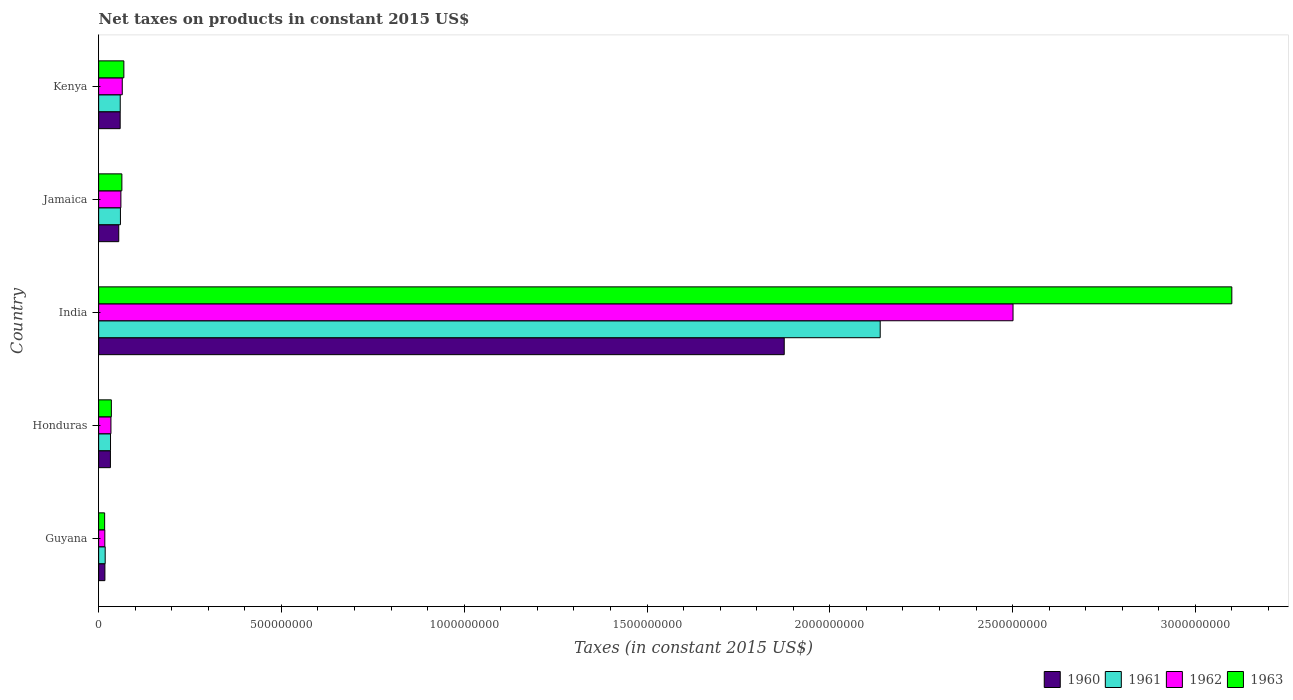How many groups of bars are there?
Your response must be concise. 5. Are the number of bars per tick equal to the number of legend labels?
Give a very brief answer. Yes. Are the number of bars on each tick of the Y-axis equal?
Your answer should be compact. Yes. How many bars are there on the 5th tick from the bottom?
Make the answer very short. 4. What is the label of the 1st group of bars from the top?
Your answer should be very brief. Kenya. In how many cases, is the number of bars for a given country not equal to the number of legend labels?
Give a very brief answer. 0. What is the net taxes on products in 1960 in Honduras?
Make the answer very short. 3.22e+07. Across all countries, what is the maximum net taxes on products in 1963?
Your answer should be very brief. 3.10e+09. Across all countries, what is the minimum net taxes on products in 1963?
Offer a terse response. 1.64e+07. In which country was the net taxes on products in 1961 maximum?
Your response must be concise. India. In which country was the net taxes on products in 1961 minimum?
Your answer should be very brief. Guyana. What is the total net taxes on products in 1960 in the graph?
Offer a terse response. 2.04e+09. What is the difference between the net taxes on products in 1962 in Guyana and that in Kenya?
Keep it short and to the point. -4.77e+07. What is the difference between the net taxes on products in 1960 in Jamaica and the net taxes on products in 1961 in India?
Give a very brief answer. -2.08e+09. What is the average net taxes on products in 1960 per country?
Make the answer very short. 4.08e+08. What is the difference between the net taxes on products in 1961 and net taxes on products in 1960 in Jamaica?
Offer a very short reply. 4.62e+06. What is the ratio of the net taxes on products in 1963 in Guyana to that in Kenya?
Your response must be concise. 0.24. What is the difference between the highest and the second highest net taxes on products in 1960?
Give a very brief answer. 1.82e+09. What is the difference between the highest and the lowest net taxes on products in 1960?
Offer a very short reply. 1.86e+09. Is the sum of the net taxes on products in 1963 in Guyana and India greater than the maximum net taxes on products in 1962 across all countries?
Offer a very short reply. Yes. Is it the case that in every country, the sum of the net taxes on products in 1960 and net taxes on products in 1963 is greater than the sum of net taxes on products in 1962 and net taxes on products in 1961?
Your response must be concise. No. Is it the case that in every country, the sum of the net taxes on products in 1960 and net taxes on products in 1962 is greater than the net taxes on products in 1963?
Provide a short and direct response. Yes. How many bars are there?
Provide a short and direct response. 20. Does the graph contain grids?
Offer a very short reply. No. How many legend labels are there?
Your answer should be very brief. 4. How are the legend labels stacked?
Your answer should be very brief. Horizontal. What is the title of the graph?
Make the answer very short. Net taxes on products in constant 2015 US$. What is the label or title of the X-axis?
Your answer should be very brief. Taxes (in constant 2015 US$). What is the Taxes (in constant 2015 US$) in 1960 in Guyana?
Offer a terse response. 1.71e+07. What is the Taxes (in constant 2015 US$) of 1961 in Guyana?
Give a very brief answer. 1.79e+07. What is the Taxes (in constant 2015 US$) in 1962 in Guyana?
Provide a succinct answer. 1.69e+07. What is the Taxes (in constant 2015 US$) of 1963 in Guyana?
Your answer should be compact. 1.64e+07. What is the Taxes (in constant 2015 US$) in 1960 in Honduras?
Make the answer very short. 3.22e+07. What is the Taxes (in constant 2015 US$) in 1961 in Honduras?
Ensure brevity in your answer.  3.25e+07. What is the Taxes (in constant 2015 US$) in 1962 in Honduras?
Give a very brief answer. 3.36e+07. What is the Taxes (in constant 2015 US$) in 1963 in Honduras?
Your response must be concise. 3.48e+07. What is the Taxes (in constant 2015 US$) of 1960 in India?
Offer a very short reply. 1.88e+09. What is the Taxes (in constant 2015 US$) of 1961 in India?
Provide a succinct answer. 2.14e+09. What is the Taxes (in constant 2015 US$) in 1962 in India?
Keep it short and to the point. 2.50e+09. What is the Taxes (in constant 2015 US$) of 1963 in India?
Provide a succinct answer. 3.10e+09. What is the Taxes (in constant 2015 US$) of 1960 in Jamaica?
Provide a succinct answer. 5.50e+07. What is the Taxes (in constant 2015 US$) in 1961 in Jamaica?
Make the answer very short. 5.96e+07. What is the Taxes (in constant 2015 US$) of 1962 in Jamaica?
Ensure brevity in your answer.  6.09e+07. What is the Taxes (in constant 2015 US$) in 1963 in Jamaica?
Give a very brief answer. 6.36e+07. What is the Taxes (in constant 2015 US$) of 1960 in Kenya?
Provide a succinct answer. 5.89e+07. What is the Taxes (in constant 2015 US$) of 1961 in Kenya?
Ensure brevity in your answer.  5.91e+07. What is the Taxes (in constant 2015 US$) of 1962 in Kenya?
Provide a succinct answer. 6.47e+07. What is the Taxes (in constant 2015 US$) of 1963 in Kenya?
Keep it short and to the point. 6.90e+07. Across all countries, what is the maximum Taxes (in constant 2015 US$) in 1960?
Keep it short and to the point. 1.88e+09. Across all countries, what is the maximum Taxes (in constant 2015 US$) in 1961?
Ensure brevity in your answer.  2.14e+09. Across all countries, what is the maximum Taxes (in constant 2015 US$) in 1962?
Provide a short and direct response. 2.50e+09. Across all countries, what is the maximum Taxes (in constant 2015 US$) in 1963?
Your response must be concise. 3.10e+09. Across all countries, what is the minimum Taxes (in constant 2015 US$) of 1960?
Your answer should be compact. 1.71e+07. Across all countries, what is the minimum Taxes (in constant 2015 US$) of 1961?
Your response must be concise. 1.79e+07. Across all countries, what is the minimum Taxes (in constant 2015 US$) of 1962?
Provide a short and direct response. 1.69e+07. Across all countries, what is the minimum Taxes (in constant 2015 US$) of 1963?
Provide a short and direct response. 1.64e+07. What is the total Taxes (in constant 2015 US$) in 1960 in the graph?
Your answer should be very brief. 2.04e+09. What is the total Taxes (in constant 2015 US$) of 1961 in the graph?
Your response must be concise. 2.31e+09. What is the total Taxes (in constant 2015 US$) in 1962 in the graph?
Offer a very short reply. 2.68e+09. What is the total Taxes (in constant 2015 US$) in 1963 in the graph?
Make the answer very short. 3.28e+09. What is the difference between the Taxes (in constant 2015 US$) in 1960 in Guyana and that in Honduras?
Provide a succinct answer. -1.51e+07. What is the difference between the Taxes (in constant 2015 US$) of 1961 in Guyana and that in Honduras?
Provide a succinct answer. -1.46e+07. What is the difference between the Taxes (in constant 2015 US$) in 1962 in Guyana and that in Honduras?
Make the answer very short. -1.67e+07. What is the difference between the Taxes (in constant 2015 US$) of 1963 in Guyana and that in Honduras?
Offer a terse response. -1.84e+07. What is the difference between the Taxes (in constant 2015 US$) in 1960 in Guyana and that in India?
Your response must be concise. -1.86e+09. What is the difference between the Taxes (in constant 2015 US$) in 1961 in Guyana and that in India?
Give a very brief answer. -2.12e+09. What is the difference between the Taxes (in constant 2015 US$) in 1962 in Guyana and that in India?
Offer a very short reply. -2.48e+09. What is the difference between the Taxes (in constant 2015 US$) of 1963 in Guyana and that in India?
Give a very brief answer. -3.08e+09. What is the difference between the Taxes (in constant 2015 US$) in 1960 in Guyana and that in Jamaica?
Give a very brief answer. -3.79e+07. What is the difference between the Taxes (in constant 2015 US$) of 1961 in Guyana and that in Jamaica?
Offer a very short reply. -4.17e+07. What is the difference between the Taxes (in constant 2015 US$) in 1962 in Guyana and that in Jamaica?
Make the answer very short. -4.40e+07. What is the difference between the Taxes (in constant 2015 US$) in 1963 in Guyana and that in Jamaica?
Give a very brief answer. -4.71e+07. What is the difference between the Taxes (in constant 2015 US$) of 1960 in Guyana and that in Kenya?
Offer a very short reply. -4.18e+07. What is the difference between the Taxes (in constant 2015 US$) in 1961 in Guyana and that in Kenya?
Provide a succinct answer. -4.12e+07. What is the difference between the Taxes (in constant 2015 US$) of 1962 in Guyana and that in Kenya?
Offer a terse response. -4.77e+07. What is the difference between the Taxes (in constant 2015 US$) in 1963 in Guyana and that in Kenya?
Make the answer very short. -5.26e+07. What is the difference between the Taxes (in constant 2015 US$) of 1960 in Honduras and that in India?
Give a very brief answer. -1.84e+09. What is the difference between the Taxes (in constant 2015 US$) of 1961 in Honduras and that in India?
Provide a short and direct response. -2.11e+09. What is the difference between the Taxes (in constant 2015 US$) of 1962 in Honduras and that in India?
Your answer should be compact. -2.47e+09. What is the difference between the Taxes (in constant 2015 US$) of 1963 in Honduras and that in India?
Offer a terse response. -3.06e+09. What is the difference between the Taxes (in constant 2015 US$) of 1960 in Honduras and that in Jamaica?
Offer a terse response. -2.28e+07. What is the difference between the Taxes (in constant 2015 US$) of 1961 in Honduras and that in Jamaica?
Your answer should be compact. -2.71e+07. What is the difference between the Taxes (in constant 2015 US$) of 1962 in Honduras and that in Jamaica?
Make the answer very short. -2.72e+07. What is the difference between the Taxes (in constant 2015 US$) in 1963 in Honduras and that in Jamaica?
Your answer should be compact. -2.88e+07. What is the difference between the Taxes (in constant 2015 US$) in 1960 in Honduras and that in Kenya?
Your answer should be compact. -2.67e+07. What is the difference between the Taxes (in constant 2015 US$) in 1961 in Honduras and that in Kenya?
Provide a short and direct response. -2.66e+07. What is the difference between the Taxes (in constant 2015 US$) in 1962 in Honduras and that in Kenya?
Your answer should be very brief. -3.10e+07. What is the difference between the Taxes (in constant 2015 US$) in 1963 in Honduras and that in Kenya?
Ensure brevity in your answer.  -3.42e+07. What is the difference between the Taxes (in constant 2015 US$) of 1960 in India and that in Jamaica?
Your response must be concise. 1.82e+09. What is the difference between the Taxes (in constant 2015 US$) in 1961 in India and that in Jamaica?
Your answer should be compact. 2.08e+09. What is the difference between the Taxes (in constant 2015 US$) in 1962 in India and that in Jamaica?
Provide a succinct answer. 2.44e+09. What is the difference between the Taxes (in constant 2015 US$) of 1963 in India and that in Jamaica?
Your answer should be very brief. 3.04e+09. What is the difference between the Taxes (in constant 2015 US$) in 1960 in India and that in Kenya?
Your answer should be compact. 1.82e+09. What is the difference between the Taxes (in constant 2015 US$) of 1961 in India and that in Kenya?
Make the answer very short. 2.08e+09. What is the difference between the Taxes (in constant 2015 US$) in 1962 in India and that in Kenya?
Make the answer very short. 2.44e+09. What is the difference between the Taxes (in constant 2015 US$) of 1963 in India and that in Kenya?
Give a very brief answer. 3.03e+09. What is the difference between the Taxes (in constant 2015 US$) in 1960 in Jamaica and that in Kenya?
Make the answer very short. -3.91e+06. What is the difference between the Taxes (in constant 2015 US$) of 1961 in Jamaica and that in Kenya?
Offer a terse response. 5.74e+05. What is the difference between the Taxes (in constant 2015 US$) in 1962 in Jamaica and that in Kenya?
Your response must be concise. -3.75e+06. What is the difference between the Taxes (in constant 2015 US$) of 1963 in Jamaica and that in Kenya?
Your response must be concise. -5.46e+06. What is the difference between the Taxes (in constant 2015 US$) in 1960 in Guyana and the Taxes (in constant 2015 US$) in 1961 in Honduras?
Offer a very short reply. -1.54e+07. What is the difference between the Taxes (in constant 2015 US$) in 1960 in Guyana and the Taxes (in constant 2015 US$) in 1962 in Honduras?
Offer a terse response. -1.65e+07. What is the difference between the Taxes (in constant 2015 US$) of 1960 in Guyana and the Taxes (in constant 2015 US$) of 1963 in Honduras?
Give a very brief answer. -1.77e+07. What is the difference between the Taxes (in constant 2015 US$) of 1961 in Guyana and the Taxes (in constant 2015 US$) of 1962 in Honduras?
Your answer should be compact. -1.57e+07. What is the difference between the Taxes (in constant 2015 US$) of 1961 in Guyana and the Taxes (in constant 2015 US$) of 1963 in Honduras?
Your answer should be very brief. -1.69e+07. What is the difference between the Taxes (in constant 2015 US$) of 1962 in Guyana and the Taxes (in constant 2015 US$) of 1963 in Honduras?
Your answer should be very brief. -1.79e+07. What is the difference between the Taxes (in constant 2015 US$) of 1960 in Guyana and the Taxes (in constant 2015 US$) of 1961 in India?
Provide a short and direct response. -2.12e+09. What is the difference between the Taxes (in constant 2015 US$) in 1960 in Guyana and the Taxes (in constant 2015 US$) in 1962 in India?
Make the answer very short. -2.48e+09. What is the difference between the Taxes (in constant 2015 US$) in 1960 in Guyana and the Taxes (in constant 2015 US$) in 1963 in India?
Make the answer very short. -3.08e+09. What is the difference between the Taxes (in constant 2015 US$) in 1961 in Guyana and the Taxes (in constant 2015 US$) in 1962 in India?
Give a very brief answer. -2.48e+09. What is the difference between the Taxes (in constant 2015 US$) of 1961 in Guyana and the Taxes (in constant 2015 US$) of 1963 in India?
Provide a succinct answer. -3.08e+09. What is the difference between the Taxes (in constant 2015 US$) in 1962 in Guyana and the Taxes (in constant 2015 US$) in 1963 in India?
Provide a succinct answer. -3.08e+09. What is the difference between the Taxes (in constant 2015 US$) in 1960 in Guyana and the Taxes (in constant 2015 US$) in 1961 in Jamaica?
Provide a short and direct response. -4.25e+07. What is the difference between the Taxes (in constant 2015 US$) in 1960 in Guyana and the Taxes (in constant 2015 US$) in 1962 in Jamaica?
Offer a very short reply. -4.38e+07. What is the difference between the Taxes (in constant 2015 US$) in 1960 in Guyana and the Taxes (in constant 2015 US$) in 1963 in Jamaica?
Offer a very short reply. -4.64e+07. What is the difference between the Taxes (in constant 2015 US$) in 1961 in Guyana and the Taxes (in constant 2015 US$) in 1962 in Jamaica?
Provide a short and direct response. -4.30e+07. What is the difference between the Taxes (in constant 2015 US$) of 1961 in Guyana and the Taxes (in constant 2015 US$) of 1963 in Jamaica?
Give a very brief answer. -4.57e+07. What is the difference between the Taxes (in constant 2015 US$) of 1962 in Guyana and the Taxes (in constant 2015 US$) of 1963 in Jamaica?
Give a very brief answer. -4.66e+07. What is the difference between the Taxes (in constant 2015 US$) in 1960 in Guyana and the Taxes (in constant 2015 US$) in 1961 in Kenya?
Offer a very short reply. -4.19e+07. What is the difference between the Taxes (in constant 2015 US$) in 1960 in Guyana and the Taxes (in constant 2015 US$) in 1962 in Kenya?
Provide a succinct answer. -4.75e+07. What is the difference between the Taxes (in constant 2015 US$) of 1960 in Guyana and the Taxes (in constant 2015 US$) of 1963 in Kenya?
Keep it short and to the point. -5.19e+07. What is the difference between the Taxes (in constant 2015 US$) of 1961 in Guyana and the Taxes (in constant 2015 US$) of 1962 in Kenya?
Offer a very short reply. -4.67e+07. What is the difference between the Taxes (in constant 2015 US$) in 1961 in Guyana and the Taxes (in constant 2015 US$) in 1963 in Kenya?
Make the answer very short. -5.11e+07. What is the difference between the Taxes (in constant 2015 US$) of 1962 in Guyana and the Taxes (in constant 2015 US$) of 1963 in Kenya?
Your answer should be very brief. -5.21e+07. What is the difference between the Taxes (in constant 2015 US$) of 1960 in Honduras and the Taxes (in constant 2015 US$) of 1961 in India?
Ensure brevity in your answer.  -2.11e+09. What is the difference between the Taxes (in constant 2015 US$) in 1960 in Honduras and the Taxes (in constant 2015 US$) in 1962 in India?
Provide a short and direct response. -2.47e+09. What is the difference between the Taxes (in constant 2015 US$) of 1960 in Honduras and the Taxes (in constant 2015 US$) of 1963 in India?
Make the answer very short. -3.07e+09. What is the difference between the Taxes (in constant 2015 US$) of 1961 in Honduras and the Taxes (in constant 2015 US$) of 1962 in India?
Provide a short and direct response. -2.47e+09. What is the difference between the Taxes (in constant 2015 US$) of 1961 in Honduras and the Taxes (in constant 2015 US$) of 1963 in India?
Make the answer very short. -3.07e+09. What is the difference between the Taxes (in constant 2015 US$) of 1962 in Honduras and the Taxes (in constant 2015 US$) of 1963 in India?
Offer a terse response. -3.07e+09. What is the difference between the Taxes (in constant 2015 US$) in 1960 in Honduras and the Taxes (in constant 2015 US$) in 1961 in Jamaica?
Ensure brevity in your answer.  -2.74e+07. What is the difference between the Taxes (in constant 2015 US$) of 1960 in Honduras and the Taxes (in constant 2015 US$) of 1962 in Jamaica?
Make the answer very short. -2.86e+07. What is the difference between the Taxes (in constant 2015 US$) of 1960 in Honduras and the Taxes (in constant 2015 US$) of 1963 in Jamaica?
Offer a very short reply. -3.13e+07. What is the difference between the Taxes (in constant 2015 US$) in 1961 in Honduras and the Taxes (in constant 2015 US$) in 1962 in Jamaica?
Provide a short and direct response. -2.84e+07. What is the difference between the Taxes (in constant 2015 US$) in 1961 in Honduras and the Taxes (in constant 2015 US$) in 1963 in Jamaica?
Make the answer very short. -3.11e+07. What is the difference between the Taxes (in constant 2015 US$) in 1962 in Honduras and the Taxes (in constant 2015 US$) in 1963 in Jamaica?
Provide a succinct answer. -2.99e+07. What is the difference between the Taxes (in constant 2015 US$) in 1960 in Honduras and the Taxes (in constant 2015 US$) in 1961 in Kenya?
Your answer should be very brief. -2.68e+07. What is the difference between the Taxes (in constant 2015 US$) of 1960 in Honduras and the Taxes (in constant 2015 US$) of 1962 in Kenya?
Ensure brevity in your answer.  -3.24e+07. What is the difference between the Taxes (in constant 2015 US$) of 1960 in Honduras and the Taxes (in constant 2015 US$) of 1963 in Kenya?
Your answer should be compact. -3.68e+07. What is the difference between the Taxes (in constant 2015 US$) of 1961 in Honduras and the Taxes (in constant 2015 US$) of 1962 in Kenya?
Ensure brevity in your answer.  -3.22e+07. What is the difference between the Taxes (in constant 2015 US$) of 1961 in Honduras and the Taxes (in constant 2015 US$) of 1963 in Kenya?
Offer a very short reply. -3.65e+07. What is the difference between the Taxes (in constant 2015 US$) in 1962 in Honduras and the Taxes (in constant 2015 US$) in 1963 in Kenya?
Your response must be concise. -3.54e+07. What is the difference between the Taxes (in constant 2015 US$) of 1960 in India and the Taxes (in constant 2015 US$) of 1961 in Jamaica?
Provide a short and direct response. 1.82e+09. What is the difference between the Taxes (in constant 2015 US$) in 1960 in India and the Taxes (in constant 2015 US$) in 1962 in Jamaica?
Give a very brief answer. 1.81e+09. What is the difference between the Taxes (in constant 2015 US$) of 1960 in India and the Taxes (in constant 2015 US$) of 1963 in Jamaica?
Make the answer very short. 1.81e+09. What is the difference between the Taxes (in constant 2015 US$) of 1961 in India and the Taxes (in constant 2015 US$) of 1962 in Jamaica?
Your answer should be very brief. 2.08e+09. What is the difference between the Taxes (in constant 2015 US$) of 1961 in India and the Taxes (in constant 2015 US$) of 1963 in Jamaica?
Provide a short and direct response. 2.07e+09. What is the difference between the Taxes (in constant 2015 US$) of 1962 in India and the Taxes (in constant 2015 US$) of 1963 in Jamaica?
Give a very brief answer. 2.44e+09. What is the difference between the Taxes (in constant 2015 US$) in 1960 in India and the Taxes (in constant 2015 US$) in 1961 in Kenya?
Keep it short and to the point. 1.82e+09. What is the difference between the Taxes (in constant 2015 US$) in 1960 in India and the Taxes (in constant 2015 US$) in 1962 in Kenya?
Provide a short and direct response. 1.81e+09. What is the difference between the Taxes (in constant 2015 US$) in 1960 in India and the Taxes (in constant 2015 US$) in 1963 in Kenya?
Ensure brevity in your answer.  1.81e+09. What is the difference between the Taxes (in constant 2015 US$) of 1961 in India and the Taxes (in constant 2015 US$) of 1962 in Kenya?
Keep it short and to the point. 2.07e+09. What is the difference between the Taxes (in constant 2015 US$) of 1961 in India and the Taxes (in constant 2015 US$) of 1963 in Kenya?
Your response must be concise. 2.07e+09. What is the difference between the Taxes (in constant 2015 US$) in 1962 in India and the Taxes (in constant 2015 US$) in 1963 in Kenya?
Your answer should be very brief. 2.43e+09. What is the difference between the Taxes (in constant 2015 US$) of 1960 in Jamaica and the Taxes (in constant 2015 US$) of 1961 in Kenya?
Your response must be concise. -4.05e+06. What is the difference between the Taxes (in constant 2015 US$) of 1960 in Jamaica and the Taxes (in constant 2015 US$) of 1962 in Kenya?
Keep it short and to the point. -9.63e+06. What is the difference between the Taxes (in constant 2015 US$) in 1960 in Jamaica and the Taxes (in constant 2015 US$) in 1963 in Kenya?
Offer a very short reply. -1.40e+07. What is the difference between the Taxes (in constant 2015 US$) of 1961 in Jamaica and the Taxes (in constant 2015 US$) of 1962 in Kenya?
Your answer should be compact. -5.01e+06. What is the difference between the Taxes (in constant 2015 US$) in 1961 in Jamaica and the Taxes (in constant 2015 US$) in 1963 in Kenya?
Provide a succinct answer. -9.38e+06. What is the difference between the Taxes (in constant 2015 US$) in 1962 in Jamaica and the Taxes (in constant 2015 US$) in 1963 in Kenya?
Make the answer very short. -8.12e+06. What is the average Taxes (in constant 2015 US$) of 1960 per country?
Give a very brief answer. 4.08e+08. What is the average Taxes (in constant 2015 US$) in 1961 per country?
Offer a very short reply. 4.61e+08. What is the average Taxes (in constant 2015 US$) of 1962 per country?
Your answer should be very brief. 5.35e+08. What is the average Taxes (in constant 2015 US$) in 1963 per country?
Offer a very short reply. 6.57e+08. What is the difference between the Taxes (in constant 2015 US$) of 1960 and Taxes (in constant 2015 US$) of 1961 in Guyana?
Keep it short and to the point. -7.58e+05. What is the difference between the Taxes (in constant 2015 US$) of 1960 and Taxes (in constant 2015 US$) of 1962 in Guyana?
Your answer should be very brief. 2.33e+05. What is the difference between the Taxes (in constant 2015 US$) in 1960 and Taxes (in constant 2015 US$) in 1963 in Guyana?
Your answer should be very brief. 7.00e+05. What is the difference between the Taxes (in constant 2015 US$) of 1961 and Taxes (in constant 2015 US$) of 1962 in Guyana?
Your answer should be compact. 9.92e+05. What is the difference between the Taxes (in constant 2015 US$) in 1961 and Taxes (in constant 2015 US$) in 1963 in Guyana?
Provide a succinct answer. 1.46e+06. What is the difference between the Taxes (in constant 2015 US$) of 1962 and Taxes (in constant 2015 US$) of 1963 in Guyana?
Your answer should be compact. 4.67e+05. What is the difference between the Taxes (in constant 2015 US$) of 1960 and Taxes (in constant 2015 US$) of 1961 in Honduras?
Offer a terse response. -2.50e+05. What is the difference between the Taxes (in constant 2015 US$) in 1960 and Taxes (in constant 2015 US$) in 1962 in Honduras?
Your response must be concise. -1.40e+06. What is the difference between the Taxes (in constant 2015 US$) in 1960 and Taxes (in constant 2015 US$) in 1963 in Honduras?
Your response must be concise. -2.55e+06. What is the difference between the Taxes (in constant 2015 US$) of 1961 and Taxes (in constant 2015 US$) of 1962 in Honduras?
Your answer should be compact. -1.15e+06. What is the difference between the Taxes (in constant 2015 US$) of 1961 and Taxes (in constant 2015 US$) of 1963 in Honduras?
Ensure brevity in your answer.  -2.30e+06. What is the difference between the Taxes (in constant 2015 US$) of 1962 and Taxes (in constant 2015 US$) of 1963 in Honduras?
Keep it short and to the point. -1.15e+06. What is the difference between the Taxes (in constant 2015 US$) of 1960 and Taxes (in constant 2015 US$) of 1961 in India?
Make the answer very short. -2.63e+08. What is the difference between the Taxes (in constant 2015 US$) of 1960 and Taxes (in constant 2015 US$) of 1962 in India?
Your response must be concise. -6.26e+08. What is the difference between the Taxes (in constant 2015 US$) in 1960 and Taxes (in constant 2015 US$) in 1963 in India?
Offer a terse response. -1.22e+09. What is the difference between the Taxes (in constant 2015 US$) in 1961 and Taxes (in constant 2015 US$) in 1962 in India?
Make the answer very short. -3.63e+08. What is the difference between the Taxes (in constant 2015 US$) of 1961 and Taxes (in constant 2015 US$) of 1963 in India?
Make the answer very short. -9.62e+08. What is the difference between the Taxes (in constant 2015 US$) in 1962 and Taxes (in constant 2015 US$) in 1963 in India?
Provide a succinct answer. -5.99e+08. What is the difference between the Taxes (in constant 2015 US$) in 1960 and Taxes (in constant 2015 US$) in 1961 in Jamaica?
Offer a terse response. -4.62e+06. What is the difference between the Taxes (in constant 2015 US$) of 1960 and Taxes (in constant 2015 US$) of 1962 in Jamaica?
Offer a very short reply. -5.88e+06. What is the difference between the Taxes (in constant 2015 US$) of 1960 and Taxes (in constant 2015 US$) of 1963 in Jamaica?
Your response must be concise. -8.54e+06. What is the difference between the Taxes (in constant 2015 US$) in 1961 and Taxes (in constant 2015 US$) in 1962 in Jamaica?
Your answer should be very brief. -1.26e+06. What is the difference between the Taxes (in constant 2015 US$) of 1961 and Taxes (in constant 2015 US$) of 1963 in Jamaica?
Ensure brevity in your answer.  -3.92e+06. What is the difference between the Taxes (in constant 2015 US$) in 1962 and Taxes (in constant 2015 US$) in 1963 in Jamaica?
Offer a terse response. -2.66e+06. What is the difference between the Taxes (in constant 2015 US$) in 1960 and Taxes (in constant 2015 US$) in 1961 in Kenya?
Your response must be concise. -1.40e+05. What is the difference between the Taxes (in constant 2015 US$) of 1960 and Taxes (in constant 2015 US$) of 1962 in Kenya?
Provide a succinct answer. -5.73e+06. What is the difference between the Taxes (in constant 2015 US$) in 1960 and Taxes (in constant 2015 US$) in 1963 in Kenya?
Your answer should be compact. -1.01e+07. What is the difference between the Taxes (in constant 2015 US$) of 1961 and Taxes (in constant 2015 US$) of 1962 in Kenya?
Your answer should be compact. -5.59e+06. What is the difference between the Taxes (in constant 2015 US$) of 1961 and Taxes (in constant 2015 US$) of 1963 in Kenya?
Provide a short and direct response. -9.95e+06. What is the difference between the Taxes (in constant 2015 US$) in 1962 and Taxes (in constant 2015 US$) in 1963 in Kenya?
Offer a very short reply. -4.37e+06. What is the ratio of the Taxes (in constant 2015 US$) of 1960 in Guyana to that in Honduras?
Give a very brief answer. 0.53. What is the ratio of the Taxes (in constant 2015 US$) of 1961 in Guyana to that in Honduras?
Keep it short and to the point. 0.55. What is the ratio of the Taxes (in constant 2015 US$) of 1962 in Guyana to that in Honduras?
Provide a succinct answer. 0.5. What is the ratio of the Taxes (in constant 2015 US$) in 1963 in Guyana to that in Honduras?
Offer a terse response. 0.47. What is the ratio of the Taxes (in constant 2015 US$) in 1960 in Guyana to that in India?
Your answer should be very brief. 0.01. What is the ratio of the Taxes (in constant 2015 US$) in 1961 in Guyana to that in India?
Your answer should be very brief. 0.01. What is the ratio of the Taxes (in constant 2015 US$) of 1962 in Guyana to that in India?
Offer a terse response. 0.01. What is the ratio of the Taxes (in constant 2015 US$) of 1963 in Guyana to that in India?
Ensure brevity in your answer.  0.01. What is the ratio of the Taxes (in constant 2015 US$) of 1960 in Guyana to that in Jamaica?
Give a very brief answer. 0.31. What is the ratio of the Taxes (in constant 2015 US$) of 1961 in Guyana to that in Jamaica?
Provide a short and direct response. 0.3. What is the ratio of the Taxes (in constant 2015 US$) in 1962 in Guyana to that in Jamaica?
Make the answer very short. 0.28. What is the ratio of the Taxes (in constant 2015 US$) in 1963 in Guyana to that in Jamaica?
Keep it short and to the point. 0.26. What is the ratio of the Taxes (in constant 2015 US$) in 1960 in Guyana to that in Kenya?
Provide a short and direct response. 0.29. What is the ratio of the Taxes (in constant 2015 US$) in 1961 in Guyana to that in Kenya?
Offer a very short reply. 0.3. What is the ratio of the Taxes (in constant 2015 US$) in 1962 in Guyana to that in Kenya?
Keep it short and to the point. 0.26. What is the ratio of the Taxes (in constant 2015 US$) of 1963 in Guyana to that in Kenya?
Offer a terse response. 0.24. What is the ratio of the Taxes (in constant 2015 US$) of 1960 in Honduras to that in India?
Your answer should be very brief. 0.02. What is the ratio of the Taxes (in constant 2015 US$) in 1961 in Honduras to that in India?
Keep it short and to the point. 0.02. What is the ratio of the Taxes (in constant 2015 US$) in 1962 in Honduras to that in India?
Make the answer very short. 0.01. What is the ratio of the Taxes (in constant 2015 US$) of 1963 in Honduras to that in India?
Give a very brief answer. 0.01. What is the ratio of the Taxes (in constant 2015 US$) in 1960 in Honduras to that in Jamaica?
Give a very brief answer. 0.59. What is the ratio of the Taxes (in constant 2015 US$) in 1961 in Honduras to that in Jamaica?
Your answer should be compact. 0.54. What is the ratio of the Taxes (in constant 2015 US$) of 1962 in Honduras to that in Jamaica?
Provide a succinct answer. 0.55. What is the ratio of the Taxes (in constant 2015 US$) of 1963 in Honduras to that in Jamaica?
Give a very brief answer. 0.55. What is the ratio of the Taxes (in constant 2015 US$) of 1960 in Honduras to that in Kenya?
Offer a terse response. 0.55. What is the ratio of the Taxes (in constant 2015 US$) of 1961 in Honduras to that in Kenya?
Keep it short and to the point. 0.55. What is the ratio of the Taxes (in constant 2015 US$) of 1962 in Honduras to that in Kenya?
Make the answer very short. 0.52. What is the ratio of the Taxes (in constant 2015 US$) in 1963 in Honduras to that in Kenya?
Your response must be concise. 0.5. What is the ratio of the Taxes (in constant 2015 US$) in 1960 in India to that in Jamaica?
Give a very brief answer. 34.08. What is the ratio of the Taxes (in constant 2015 US$) in 1961 in India to that in Jamaica?
Your answer should be very brief. 35.85. What is the ratio of the Taxes (in constant 2015 US$) of 1962 in India to that in Jamaica?
Ensure brevity in your answer.  41.07. What is the ratio of the Taxes (in constant 2015 US$) of 1963 in India to that in Jamaica?
Keep it short and to the point. 48.77. What is the ratio of the Taxes (in constant 2015 US$) of 1960 in India to that in Kenya?
Provide a short and direct response. 31.82. What is the ratio of the Taxes (in constant 2015 US$) of 1961 in India to that in Kenya?
Offer a very short reply. 36.19. What is the ratio of the Taxes (in constant 2015 US$) of 1962 in India to that in Kenya?
Give a very brief answer. 38.69. What is the ratio of the Taxes (in constant 2015 US$) of 1963 in India to that in Kenya?
Offer a very short reply. 44.91. What is the ratio of the Taxes (in constant 2015 US$) of 1960 in Jamaica to that in Kenya?
Make the answer very short. 0.93. What is the ratio of the Taxes (in constant 2015 US$) of 1961 in Jamaica to that in Kenya?
Provide a short and direct response. 1.01. What is the ratio of the Taxes (in constant 2015 US$) of 1962 in Jamaica to that in Kenya?
Your answer should be compact. 0.94. What is the ratio of the Taxes (in constant 2015 US$) in 1963 in Jamaica to that in Kenya?
Provide a succinct answer. 0.92. What is the difference between the highest and the second highest Taxes (in constant 2015 US$) in 1960?
Ensure brevity in your answer.  1.82e+09. What is the difference between the highest and the second highest Taxes (in constant 2015 US$) of 1961?
Provide a short and direct response. 2.08e+09. What is the difference between the highest and the second highest Taxes (in constant 2015 US$) in 1962?
Give a very brief answer. 2.44e+09. What is the difference between the highest and the second highest Taxes (in constant 2015 US$) of 1963?
Provide a short and direct response. 3.03e+09. What is the difference between the highest and the lowest Taxes (in constant 2015 US$) of 1960?
Your response must be concise. 1.86e+09. What is the difference between the highest and the lowest Taxes (in constant 2015 US$) of 1961?
Your answer should be compact. 2.12e+09. What is the difference between the highest and the lowest Taxes (in constant 2015 US$) in 1962?
Offer a very short reply. 2.48e+09. What is the difference between the highest and the lowest Taxes (in constant 2015 US$) in 1963?
Provide a succinct answer. 3.08e+09. 